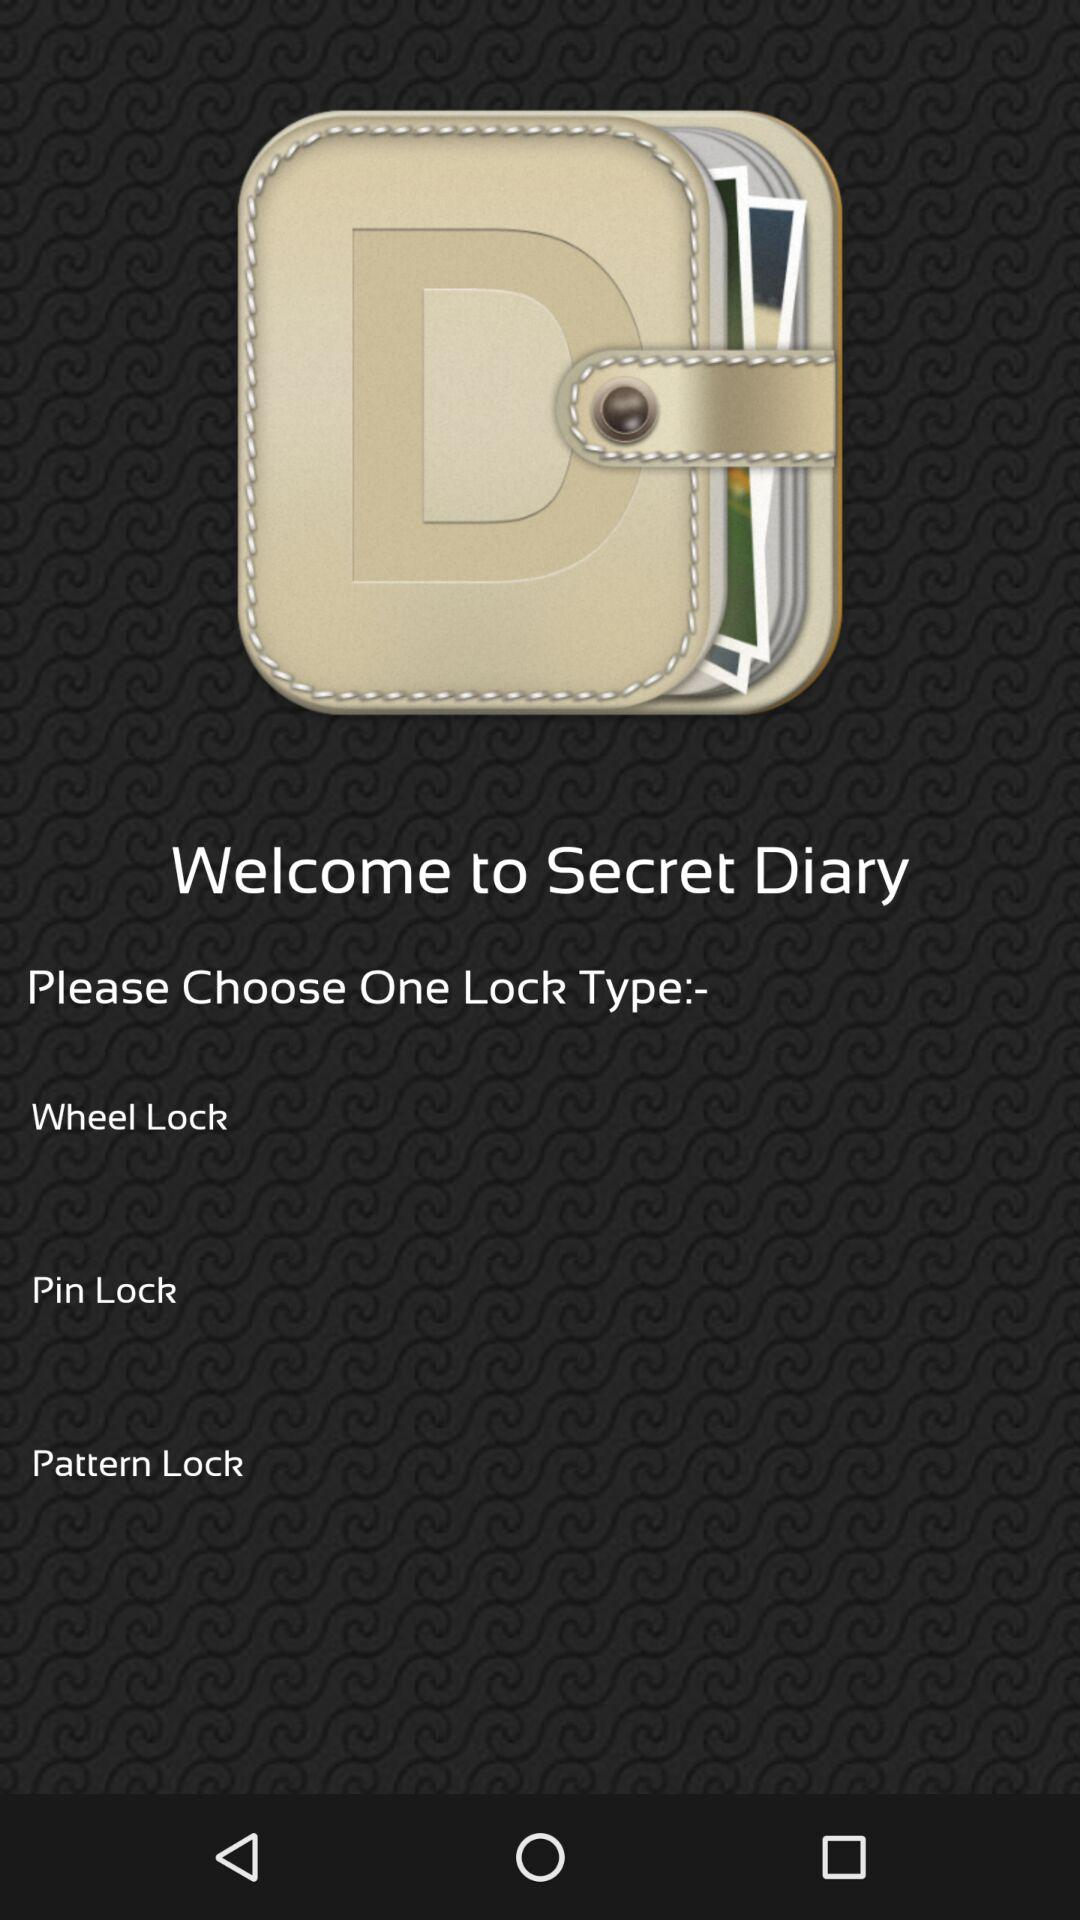What is the application name? The application name is "Secret Diary". 